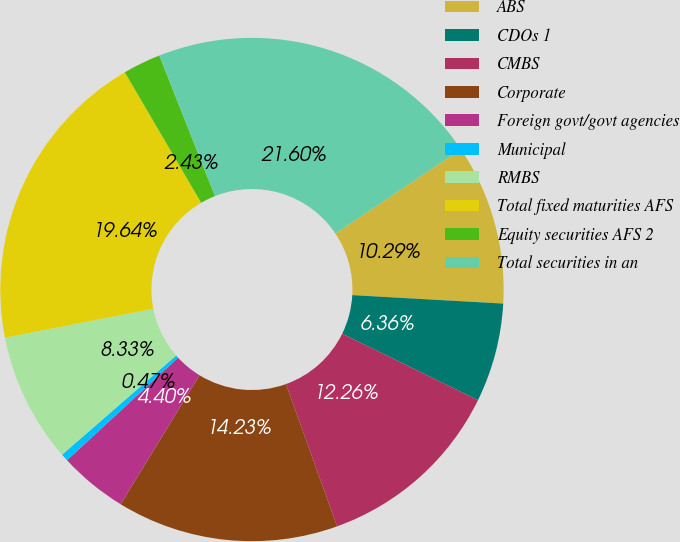<chart> <loc_0><loc_0><loc_500><loc_500><pie_chart><fcel>ABS<fcel>CDOs 1<fcel>CMBS<fcel>Corporate<fcel>Foreign govt/govt agencies<fcel>Municipal<fcel>RMBS<fcel>Total fixed maturities AFS<fcel>Equity securities AFS 2<fcel>Total securities in an<nl><fcel>10.29%<fcel>6.36%<fcel>12.26%<fcel>14.23%<fcel>4.4%<fcel>0.47%<fcel>8.33%<fcel>19.64%<fcel>2.43%<fcel>21.6%<nl></chart> 